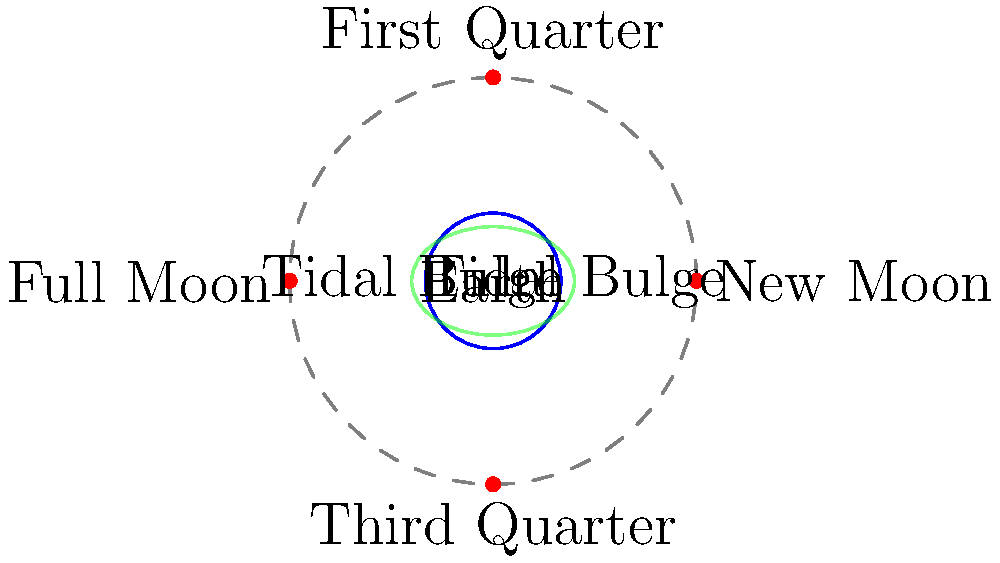As the regional governor responsible for coastal management, you need to understand the relationship between lunar phases and tidal patterns. Based on the diagram, which lunar phase(s) would result in the most extreme tidal ranges, and why is this crucial for implementing effective coastal policies? To answer this question, let's break down the relationship between lunar phases and tidal patterns:

1. Tidal forces are primarily caused by the gravitational pull of the Moon on Earth's oceans.

2. The diagram shows the Moon's orbit around Earth and its four main phases: New Moon, Full Moon, First Quarter, and Third Quarter.

3. Tidal bulges are represented by the green ellipse around Earth. These bulges occur on opposite sides of Earth due to the combined effects of the Moon's gravity and Earth's rotation.

4. The most extreme tides, called spring tides, occur when the tidal forces of the Sun and Moon align. This happens during New Moon and Full Moon phases.

5. During New Moon and Full Moon, the Sun, Earth, and Moon are in a straight line (syzygy). This alignment causes the gravitational pulls of the Sun and Moon to combine, resulting in higher high tides and lower low tides.

6. First Quarter and Third Quarter Moon phases produce less extreme tides, called neap tides, as the Sun and Moon's gravitational forces are at right angles to each other, partially canceling out their effects.

7. Understanding these patterns is crucial for coastal management because:
   a. Extreme tides can lead to coastal flooding and erosion.
   b. They affect maritime activities, such as shipping and fishing.
   c. They impact coastal ecosystems and habitats.
   d. Infrastructure planning and development in coastal areas must account for tidal ranges.

8. As a governor, this knowledge allows for:
   a. Implementing appropriate flood defense systems.
   b. Scheduling maintenance of coastal structures during periods of lower tidal ranges.
   c. Developing policies for sustainable coastal development.
   d. Preparing emergency response plans for potential flooding events during spring tides.
Answer: New Moon and Full Moon phases; crucial for flood prevention, coastal development, and emergency planning. 